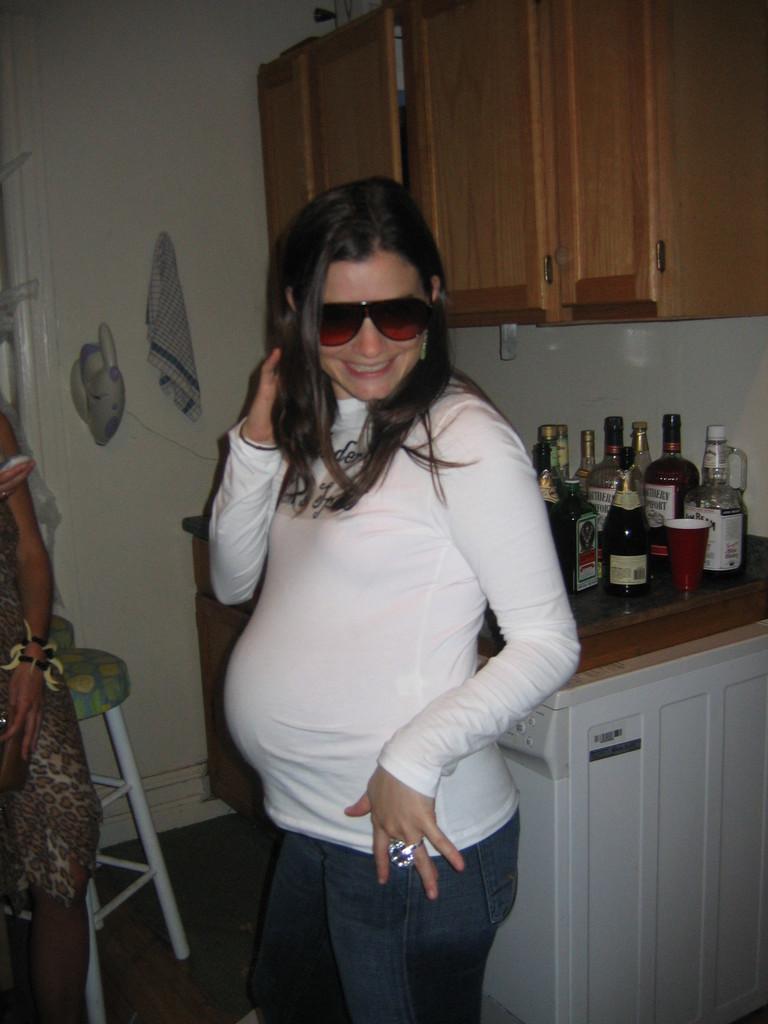Can you describe this image briefly? In this image I can see two persons are standing on the floor. In the background I can see a stool, cabinet, wall, bottles, cups and shelves. This image is taken may be in a room. 